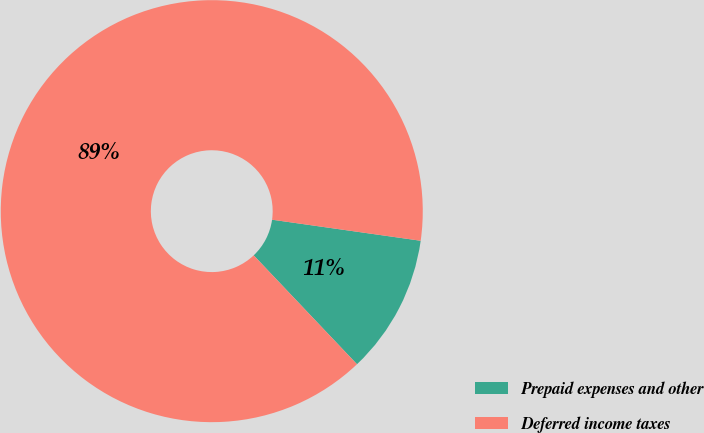<chart> <loc_0><loc_0><loc_500><loc_500><pie_chart><fcel>Prepaid expenses and other<fcel>Deferred income taxes<nl><fcel>10.68%<fcel>89.32%<nl></chart> 